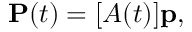<formula> <loc_0><loc_0><loc_500><loc_500>P ( t ) = [ A ( t ) ] p ,</formula> 